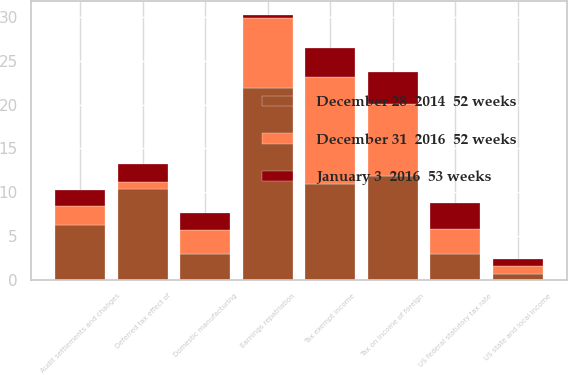<chart> <loc_0><loc_0><loc_500><loc_500><stacked_bar_chart><ecel><fcel>US federal statutory tax rate<fcel>Tax on income of foreign<fcel>Domestic manufacturing<fcel>US state and local income<fcel>Earnings repatriation<fcel>Tax exempt income<fcel>Deferred tax effect of<fcel>Audit settlements and changes<nl><fcel>January 3  2016  53 weeks<fcel>2.9<fcel>3.6<fcel>1.9<fcel>0.8<fcel>0.4<fcel>3.3<fcel>2<fcel>1.8<nl><fcel>December 28  2014  52 weeks<fcel>2.9<fcel>11.8<fcel>2.9<fcel>0.6<fcel>21.9<fcel>10.9<fcel>10.4<fcel>6.2<nl><fcel>December 31  2016  52 weeks<fcel>2.9<fcel>8.3<fcel>2.8<fcel>0.9<fcel>8<fcel>12.3<fcel>0.8<fcel>2.2<nl></chart> 